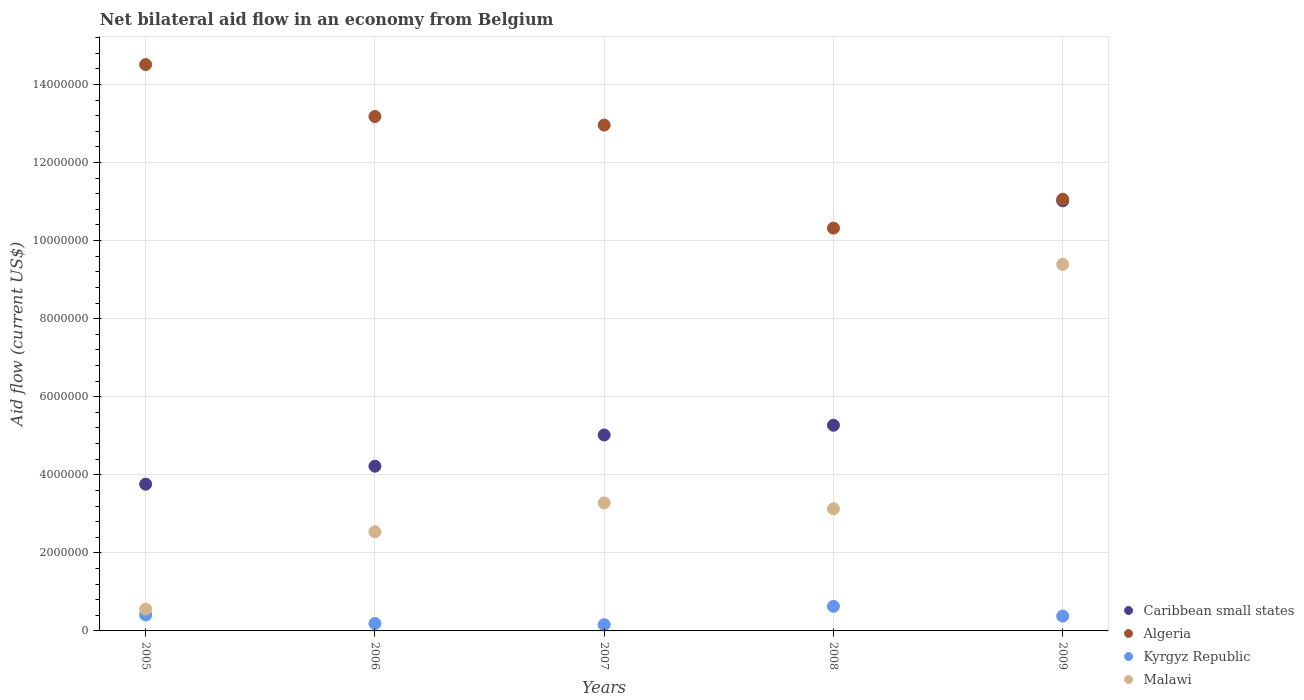How many different coloured dotlines are there?
Offer a terse response. 4. Is the number of dotlines equal to the number of legend labels?
Ensure brevity in your answer.  Yes. What is the net bilateral aid flow in Algeria in 2008?
Make the answer very short. 1.03e+07. Across all years, what is the maximum net bilateral aid flow in Algeria?
Provide a succinct answer. 1.45e+07. Across all years, what is the minimum net bilateral aid flow in Malawi?
Keep it short and to the point. 5.60e+05. What is the total net bilateral aid flow in Kyrgyz Republic in the graph?
Your answer should be very brief. 1.77e+06. What is the difference between the net bilateral aid flow in Malawi in 2005 and the net bilateral aid flow in Caribbean small states in 2008?
Keep it short and to the point. -4.71e+06. What is the average net bilateral aid flow in Algeria per year?
Make the answer very short. 1.24e+07. In the year 2006, what is the difference between the net bilateral aid flow in Kyrgyz Republic and net bilateral aid flow in Algeria?
Ensure brevity in your answer.  -1.30e+07. Is the net bilateral aid flow in Caribbean small states in 2006 less than that in 2008?
Provide a succinct answer. Yes. Is the difference between the net bilateral aid flow in Kyrgyz Republic in 2005 and 2009 greater than the difference between the net bilateral aid flow in Algeria in 2005 and 2009?
Your response must be concise. No. What is the difference between the highest and the second highest net bilateral aid flow in Malawi?
Give a very brief answer. 6.11e+06. What is the difference between the highest and the lowest net bilateral aid flow in Kyrgyz Republic?
Your answer should be very brief. 4.70e+05. In how many years, is the net bilateral aid flow in Caribbean small states greater than the average net bilateral aid flow in Caribbean small states taken over all years?
Provide a succinct answer. 1. Is the net bilateral aid flow in Algeria strictly greater than the net bilateral aid flow in Caribbean small states over the years?
Keep it short and to the point. Yes. Is the net bilateral aid flow in Malawi strictly less than the net bilateral aid flow in Kyrgyz Republic over the years?
Make the answer very short. No. How many dotlines are there?
Provide a succinct answer. 4. How many years are there in the graph?
Ensure brevity in your answer.  5. Are the values on the major ticks of Y-axis written in scientific E-notation?
Make the answer very short. No. What is the title of the graph?
Your answer should be very brief. Net bilateral aid flow in an economy from Belgium. What is the Aid flow (current US$) in Caribbean small states in 2005?
Keep it short and to the point. 3.76e+06. What is the Aid flow (current US$) in Algeria in 2005?
Your answer should be very brief. 1.45e+07. What is the Aid flow (current US$) of Malawi in 2005?
Keep it short and to the point. 5.60e+05. What is the Aid flow (current US$) of Caribbean small states in 2006?
Give a very brief answer. 4.22e+06. What is the Aid flow (current US$) in Algeria in 2006?
Keep it short and to the point. 1.32e+07. What is the Aid flow (current US$) in Kyrgyz Republic in 2006?
Offer a terse response. 1.90e+05. What is the Aid flow (current US$) of Malawi in 2006?
Ensure brevity in your answer.  2.54e+06. What is the Aid flow (current US$) in Caribbean small states in 2007?
Your response must be concise. 5.02e+06. What is the Aid flow (current US$) of Algeria in 2007?
Give a very brief answer. 1.30e+07. What is the Aid flow (current US$) of Kyrgyz Republic in 2007?
Offer a very short reply. 1.60e+05. What is the Aid flow (current US$) of Malawi in 2007?
Keep it short and to the point. 3.28e+06. What is the Aid flow (current US$) in Caribbean small states in 2008?
Offer a very short reply. 5.27e+06. What is the Aid flow (current US$) of Algeria in 2008?
Provide a short and direct response. 1.03e+07. What is the Aid flow (current US$) in Kyrgyz Republic in 2008?
Your answer should be very brief. 6.30e+05. What is the Aid flow (current US$) in Malawi in 2008?
Provide a succinct answer. 3.13e+06. What is the Aid flow (current US$) of Caribbean small states in 2009?
Offer a terse response. 1.10e+07. What is the Aid flow (current US$) of Algeria in 2009?
Provide a succinct answer. 1.11e+07. What is the Aid flow (current US$) of Kyrgyz Republic in 2009?
Your answer should be compact. 3.80e+05. What is the Aid flow (current US$) of Malawi in 2009?
Your response must be concise. 9.39e+06. Across all years, what is the maximum Aid flow (current US$) in Caribbean small states?
Keep it short and to the point. 1.10e+07. Across all years, what is the maximum Aid flow (current US$) in Algeria?
Make the answer very short. 1.45e+07. Across all years, what is the maximum Aid flow (current US$) in Kyrgyz Republic?
Offer a very short reply. 6.30e+05. Across all years, what is the maximum Aid flow (current US$) of Malawi?
Offer a terse response. 9.39e+06. Across all years, what is the minimum Aid flow (current US$) of Caribbean small states?
Ensure brevity in your answer.  3.76e+06. Across all years, what is the minimum Aid flow (current US$) in Algeria?
Provide a succinct answer. 1.03e+07. Across all years, what is the minimum Aid flow (current US$) in Malawi?
Keep it short and to the point. 5.60e+05. What is the total Aid flow (current US$) of Caribbean small states in the graph?
Provide a short and direct response. 2.93e+07. What is the total Aid flow (current US$) in Algeria in the graph?
Provide a short and direct response. 6.20e+07. What is the total Aid flow (current US$) in Kyrgyz Republic in the graph?
Give a very brief answer. 1.77e+06. What is the total Aid flow (current US$) of Malawi in the graph?
Make the answer very short. 1.89e+07. What is the difference between the Aid flow (current US$) in Caribbean small states in 2005 and that in 2006?
Provide a succinct answer. -4.60e+05. What is the difference between the Aid flow (current US$) of Algeria in 2005 and that in 2006?
Make the answer very short. 1.33e+06. What is the difference between the Aid flow (current US$) of Kyrgyz Republic in 2005 and that in 2006?
Your answer should be very brief. 2.20e+05. What is the difference between the Aid flow (current US$) of Malawi in 2005 and that in 2006?
Your answer should be compact. -1.98e+06. What is the difference between the Aid flow (current US$) in Caribbean small states in 2005 and that in 2007?
Your answer should be very brief. -1.26e+06. What is the difference between the Aid flow (current US$) of Algeria in 2005 and that in 2007?
Offer a very short reply. 1.55e+06. What is the difference between the Aid flow (current US$) of Malawi in 2005 and that in 2007?
Ensure brevity in your answer.  -2.72e+06. What is the difference between the Aid flow (current US$) of Caribbean small states in 2005 and that in 2008?
Offer a very short reply. -1.51e+06. What is the difference between the Aid flow (current US$) in Algeria in 2005 and that in 2008?
Your answer should be compact. 4.19e+06. What is the difference between the Aid flow (current US$) of Kyrgyz Republic in 2005 and that in 2008?
Keep it short and to the point. -2.20e+05. What is the difference between the Aid flow (current US$) in Malawi in 2005 and that in 2008?
Your answer should be very brief. -2.57e+06. What is the difference between the Aid flow (current US$) of Caribbean small states in 2005 and that in 2009?
Your answer should be compact. -7.26e+06. What is the difference between the Aid flow (current US$) of Algeria in 2005 and that in 2009?
Offer a very short reply. 3.45e+06. What is the difference between the Aid flow (current US$) in Kyrgyz Republic in 2005 and that in 2009?
Your answer should be very brief. 3.00e+04. What is the difference between the Aid flow (current US$) in Malawi in 2005 and that in 2009?
Provide a short and direct response. -8.83e+06. What is the difference between the Aid flow (current US$) of Caribbean small states in 2006 and that in 2007?
Keep it short and to the point. -8.00e+05. What is the difference between the Aid flow (current US$) in Algeria in 2006 and that in 2007?
Make the answer very short. 2.20e+05. What is the difference between the Aid flow (current US$) of Malawi in 2006 and that in 2007?
Provide a succinct answer. -7.40e+05. What is the difference between the Aid flow (current US$) of Caribbean small states in 2006 and that in 2008?
Provide a short and direct response. -1.05e+06. What is the difference between the Aid flow (current US$) in Algeria in 2006 and that in 2008?
Make the answer very short. 2.86e+06. What is the difference between the Aid flow (current US$) in Kyrgyz Republic in 2006 and that in 2008?
Make the answer very short. -4.40e+05. What is the difference between the Aid flow (current US$) in Malawi in 2006 and that in 2008?
Make the answer very short. -5.90e+05. What is the difference between the Aid flow (current US$) of Caribbean small states in 2006 and that in 2009?
Provide a succinct answer. -6.80e+06. What is the difference between the Aid flow (current US$) of Algeria in 2006 and that in 2009?
Ensure brevity in your answer.  2.12e+06. What is the difference between the Aid flow (current US$) of Kyrgyz Republic in 2006 and that in 2009?
Give a very brief answer. -1.90e+05. What is the difference between the Aid flow (current US$) in Malawi in 2006 and that in 2009?
Your response must be concise. -6.85e+06. What is the difference between the Aid flow (current US$) of Algeria in 2007 and that in 2008?
Offer a terse response. 2.64e+06. What is the difference between the Aid flow (current US$) of Kyrgyz Republic in 2007 and that in 2008?
Provide a succinct answer. -4.70e+05. What is the difference between the Aid flow (current US$) in Malawi in 2007 and that in 2008?
Give a very brief answer. 1.50e+05. What is the difference between the Aid flow (current US$) of Caribbean small states in 2007 and that in 2009?
Provide a succinct answer. -6.00e+06. What is the difference between the Aid flow (current US$) in Algeria in 2007 and that in 2009?
Keep it short and to the point. 1.90e+06. What is the difference between the Aid flow (current US$) of Kyrgyz Republic in 2007 and that in 2009?
Give a very brief answer. -2.20e+05. What is the difference between the Aid flow (current US$) of Malawi in 2007 and that in 2009?
Your response must be concise. -6.11e+06. What is the difference between the Aid flow (current US$) of Caribbean small states in 2008 and that in 2009?
Make the answer very short. -5.75e+06. What is the difference between the Aid flow (current US$) in Algeria in 2008 and that in 2009?
Provide a succinct answer. -7.40e+05. What is the difference between the Aid flow (current US$) of Malawi in 2008 and that in 2009?
Offer a terse response. -6.26e+06. What is the difference between the Aid flow (current US$) of Caribbean small states in 2005 and the Aid flow (current US$) of Algeria in 2006?
Keep it short and to the point. -9.42e+06. What is the difference between the Aid flow (current US$) of Caribbean small states in 2005 and the Aid flow (current US$) of Kyrgyz Republic in 2006?
Give a very brief answer. 3.57e+06. What is the difference between the Aid flow (current US$) in Caribbean small states in 2005 and the Aid flow (current US$) in Malawi in 2006?
Offer a very short reply. 1.22e+06. What is the difference between the Aid flow (current US$) of Algeria in 2005 and the Aid flow (current US$) of Kyrgyz Republic in 2006?
Your answer should be compact. 1.43e+07. What is the difference between the Aid flow (current US$) of Algeria in 2005 and the Aid flow (current US$) of Malawi in 2006?
Make the answer very short. 1.20e+07. What is the difference between the Aid flow (current US$) in Kyrgyz Republic in 2005 and the Aid flow (current US$) in Malawi in 2006?
Keep it short and to the point. -2.13e+06. What is the difference between the Aid flow (current US$) in Caribbean small states in 2005 and the Aid flow (current US$) in Algeria in 2007?
Your response must be concise. -9.20e+06. What is the difference between the Aid flow (current US$) in Caribbean small states in 2005 and the Aid flow (current US$) in Kyrgyz Republic in 2007?
Provide a succinct answer. 3.60e+06. What is the difference between the Aid flow (current US$) in Algeria in 2005 and the Aid flow (current US$) in Kyrgyz Republic in 2007?
Your response must be concise. 1.44e+07. What is the difference between the Aid flow (current US$) in Algeria in 2005 and the Aid flow (current US$) in Malawi in 2007?
Give a very brief answer. 1.12e+07. What is the difference between the Aid flow (current US$) of Kyrgyz Republic in 2005 and the Aid flow (current US$) of Malawi in 2007?
Provide a succinct answer. -2.87e+06. What is the difference between the Aid flow (current US$) of Caribbean small states in 2005 and the Aid flow (current US$) of Algeria in 2008?
Your response must be concise. -6.56e+06. What is the difference between the Aid flow (current US$) in Caribbean small states in 2005 and the Aid flow (current US$) in Kyrgyz Republic in 2008?
Keep it short and to the point. 3.13e+06. What is the difference between the Aid flow (current US$) in Caribbean small states in 2005 and the Aid flow (current US$) in Malawi in 2008?
Offer a terse response. 6.30e+05. What is the difference between the Aid flow (current US$) of Algeria in 2005 and the Aid flow (current US$) of Kyrgyz Republic in 2008?
Make the answer very short. 1.39e+07. What is the difference between the Aid flow (current US$) in Algeria in 2005 and the Aid flow (current US$) in Malawi in 2008?
Give a very brief answer. 1.14e+07. What is the difference between the Aid flow (current US$) of Kyrgyz Republic in 2005 and the Aid flow (current US$) of Malawi in 2008?
Offer a terse response. -2.72e+06. What is the difference between the Aid flow (current US$) of Caribbean small states in 2005 and the Aid flow (current US$) of Algeria in 2009?
Offer a terse response. -7.30e+06. What is the difference between the Aid flow (current US$) of Caribbean small states in 2005 and the Aid flow (current US$) of Kyrgyz Republic in 2009?
Keep it short and to the point. 3.38e+06. What is the difference between the Aid flow (current US$) in Caribbean small states in 2005 and the Aid flow (current US$) in Malawi in 2009?
Provide a succinct answer. -5.63e+06. What is the difference between the Aid flow (current US$) in Algeria in 2005 and the Aid flow (current US$) in Kyrgyz Republic in 2009?
Your answer should be compact. 1.41e+07. What is the difference between the Aid flow (current US$) of Algeria in 2005 and the Aid flow (current US$) of Malawi in 2009?
Offer a very short reply. 5.12e+06. What is the difference between the Aid flow (current US$) of Kyrgyz Republic in 2005 and the Aid flow (current US$) of Malawi in 2009?
Your response must be concise. -8.98e+06. What is the difference between the Aid flow (current US$) of Caribbean small states in 2006 and the Aid flow (current US$) of Algeria in 2007?
Give a very brief answer. -8.74e+06. What is the difference between the Aid flow (current US$) in Caribbean small states in 2006 and the Aid flow (current US$) in Kyrgyz Republic in 2007?
Provide a succinct answer. 4.06e+06. What is the difference between the Aid flow (current US$) in Caribbean small states in 2006 and the Aid flow (current US$) in Malawi in 2007?
Ensure brevity in your answer.  9.40e+05. What is the difference between the Aid flow (current US$) of Algeria in 2006 and the Aid flow (current US$) of Kyrgyz Republic in 2007?
Keep it short and to the point. 1.30e+07. What is the difference between the Aid flow (current US$) of Algeria in 2006 and the Aid flow (current US$) of Malawi in 2007?
Offer a terse response. 9.90e+06. What is the difference between the Aid flow (current US$) of Kyrgyz Republic in 2006 and the Aid flow (current US$) of Malawi in 2007?
Keep it short and to the point. -3.09e+06. What is the difference between the Aid flow (current US$) of Caribbean small states in 2006 and the Aid flow (current US$) of Algeria in 2008?
Offer a terse response. -6.10e+06. What is the difference between the Aid flow (current US$) of Caribbean small states in 2006 and the Aid flow (current US$) of Kyrgyz Republic in 2008?
Your response must be concise. 3.59e+06. What is the difference between the Aid flow (current US$) in Caribbean small states in 2006 and the Aid flow (current US$) in Malawi in 2008?
Offer a very short reply. 1.09e+06. What is the difference between the Aid flow (current US$) in Algeria in 2006 and the Aid flow (current US$) in Kyrgyz Republic in 2008?
Your answer should be very brief. 1.26e+07. What is the difference between the Aid flow (current US$) in Algeria in 2006 and the Aid flow (current US$) in Malawi in 2008?
Provide a succinct answer. 1.00e+07. What is the difference between the Aid flow (current US$) of Kyrgyz Republic in 2006 and the Aid flow (current US$) of Malawi in 2008?
Your answer should be compact. -2.94e+06. What is the difference between the Aid flow (current US$) of Caribbean small states in 2006 and the Aid flow (current US$) of Algeria in 2009?
Your response must be concise. -6.84e+06. What is the difference between the Aid flow (current US$) in Caribbean small states in 2006 and the Aid flow (current US$) in Kyrgyz Republic in 2009?
Ensure brevity in your answer.  3.84e+06. What is the difference between the Aid flow (current US$) of Caribbean small states in 2006 and the Aid flow (current US$) of Malawi in 2009?
Ensure brevity in your answer.  -5.17e+06. What is the difference between the Aid flow (current US$) of Algeria in 2006 and the Aid flow (current US$) of Kyrgyz Republic in 2009?
Provide a short and direct response. 1.28e+07. What is the difference between the Aid flow (current US$) of Algeria in 2006 and the Aid flow (current US$) of Malawi in 2009?
Ensure brevity in your answer.  3.79e+06. What is the difference between the Aid flow (current US$) in Kyrgyz Republic in 2006 and the Aid flow (current US$) in Malawi in 2009?
Your answer should be very brief. -9.20e+06. What is the difference between the Aid flow (current US$) in Caribbean small states in 2007 and the Aid flow (current US$) in Algeria in 2008?
Provide a succinct answer. -5.30e+06. What is the difference between the Aid flow (current US$) of Caribbean small states in 2007 and the Aid flow (current US$) of Kyrgyz Republic in 2008?
Make the answer very short. 4.39e+06. What is the difference between the Aid flow (current US$) in Caribbean small states in 2007 and the Aid flow (current US$) in Malawi in 2008?
Ensure brevity in your answer.  1.89e+06. What is the difference between the Aid flow (current US$) in Algeria in 2007 and the Aid flow (current US$) in Kyrgyz Republic in 2008?
Provide a succinct answer. 1.23e+07. What is the difference between the Aid flow (current US$) of Algeria in 2007 and the Aid flow (current US$) of Malawi in 2008?
Your answer should be very brief. 9.83e+06. What is the difference between the Aid flow (current US$) in Kyrgyz Republic in 2007 and the Aid flow (current US$) in Malawi in 2008?
Offer a very short reply. -2.97e+06. What is the difference between the Aid flow (current US$) in Caribbean small states in 2007 and the Aid flow (current US$) in Algeria in 2009?
Your answer should be very brief. -6.04e+06. What is the difference between the Aid flow (current US$) in Caribbean small states in 2007 and the Aid flow (current US$) in Kyrgyz Republic in 2009?
Ensure brevity in your answer.  4.64e+06. What is the difference between the Aid flow (current US$) of Caribbean small states in 2007 and the Aid flow (current US$) of Malawi in 2009?
Your answer should be very brief. -4.37e+06. What is the difference between the Aid flow (current US$) in Algeria in 2007 and the Aid flow (current US$) in Kyrgyz Republic in 2009?
Make the answer very short. 1.26e+07. What is the difference between the Aid flow (current US$) of Algeria in 2007 and the Aid flow (current US$) of Malawi in 2009?
Your response must be concise. 3.57e+06. What is the difference between the Aid flow (current US$) in Kyrgyz Republic in 2007 and the Aid flow (current US$) in Malawi in 2009?
Provide a short and direct response. -9.23e+06. What is the difference between the Aid flow (current US$) of Caribbean small states in 2008 and the Aid flow (current US$) of Algeria in 2009?
Your response must be concise. -5.79e+06. What is the difference between the Aid flow (current US$) in Caribbean small states in 2008 and the Aid flow (current US$) in Kyrgyz Republic in 2009?
Keep it short and to the point. 4.89e+06. What is the difference between the Aid flow (current US$) of Caribbean small states in 2008 and the Aid flow (current US$) of Malawi in 2009?
Give a very brief answer. -4.12e+06. What is the difference between the Aid flow (current US$) in Algeria in 2008 and the Aid flow (current US$) in Kyrgyz Republic in 2009?
Your answer should be very brief. 9.94e+06. What is the difference between the Aid flow (current US$) in Algeria in 2008 and the Aid flow (current US$) in Malawi in 2009?
Provide a succinct answer. 9.30e+05. What is the difference between the Aid flow (current US$) in Kyrgyz Republic in 2008 and the Aid flow (current US$) in Malawi in 2009?
Your answer should be very brief. -8.76e+06. What is the average Aid flow (current US$) of Caribbean small states per year?
Make the answer very short. 5.86e+06. What is the average Aid flow (current US$) of Algeria per year?
Provide a short and direct response. 1.24e+07. What is the average Aid flow (current US$) in Kyrgyz Republic per year?
Make the answer very short. 3.54e+05. What is the average Aid flow (current US$) of Malawi per year?
Ensure brevity in your answer.  3.78e+06. In the year 2005, what is the difference between the Aid flow (current US$) in Caribbean small states and Aid flow (current US$) in Algeria?
Provide a succinct answer. -1.08e+07. In the year 2005, what is the difference between the Aid flow (current US$) in Caribbean small states and Aid flow (current US$) in Kyrgyz Republic?
Ensure brevity in your answer.  3.35e+06. In the year 2005, what is the difference between the Aid flow (current US$) of Caribbean small states and Aid flow (current US$) of Malawi?
Your response must be concise. 3.20e+06. In the year 2005, what is the difference between the Aid flow (current US$) in Algeria and Aid flow (current US$) in Kyrgyz Republic?
Your response must be concise. 1.41e+07. In the year 2005, what is the difference between the Aid flow (current US$) in Algeria and Aid flow (current US$) in Malawi?
Ensure brevity in your answer.  1.40e+07. In the year 2006, what is the difference between the Aid flow (current US$) in Caribbean small states and Aid flow (current US$) in Algeria?
Make the answer very short. -8.96e+06. In the year 2006, what is the difference between the Aid flow (current US$) in Caribbean small states and Aid flow (current US$) in Kyrgyz Republic?
Provide a succinct answer. 4.03e+06. In the year 2006, what is the difference between the Aid flow (current US$) of Caribbean small states and Aid flow (current US$) of Malawi?
Your response must be concise. 1.68e+06. In the year 2006, what is the difference between the Aid flow (current US$) in Algeria and Aid flow (current US$) in Kyrgyz Republic?
Give a very brief answer. 1.30e+07. In the year 2006, what is the difference between the Aid flow (current US$) of Algeria and Aid flow (current US$) of Malawi?
Offer a very short reply. 1.06e+07. In the year 2006, what is the difference between the Aid flow (current US$) in Kyrgyz Republic and Aid flow (current US$) in Malawi?
Your answer should be compact. -2.35e+06. In the year 2007, what is the difference between the Aid flow (current US$) in Caribbean small states and Aid flow (current US$) in Algeria?
Make the answer very short. -7.94e+06. In the year 2007, what is the difference between the Aid flow (current US$) of Caribbean small states and Aid flow (current US$) of Kyrgyz Republic?
Give a very brief answer. 4.86e+06. In the year 2007, what is the difference between the Aid flow (current US$) in Caribbean small states and Aid flow (current US$) in Malawi?
Your response must be concise. 1.74e+06. In the year 2007, what is the difference between the Aid flow (current US$) of Algeria and Aid flow (current US$) of Kyrgyz Republic?
Your answer should be very brief. 1.28e+07. In the year 2007, what is the difference between the Aid flow (current US$) in Algeria and Aid flow (current US$) in Malawi?
Offer a terse response. 9.68e+06. In the year 2007, what is the difference between the Aid flow (current US$) in Kyrgyz Republic and Aid flow (current US$) in Malawi?
Give a very brief answer. -3.12e+06. In the year 2008, what is the difference between the Aid flow (current US$) in Caribbean small states and Aid flow (current US$) in Algeria?
Ensure brevity in your answer.  -5.05e+06. In the year 2008, what is the difference between the Aid flow (current US$) in Caribbean small states and Aid flow (current US$) in Kyrgyz Republic?
Your response must be concise. 4.64e+06. In the year 2008, what is the difference between the Aid flow (current US$) in Caribbean small states and Aid flow (current US$) in Malawi?
Give a very brief answer. 2.14e+06. In the year 2008, what is the difference between the Aid flow (current US$) of Algeria and Aid flow (current US$) of Kyrgyz Republic?
Give a very brief answer. 9.69e+06. In the year 2008, what is the difference between the Aid flow (current US$) in Algeria and Aid flow (current US$) in Malawi?
Give a very brief answer. 7.19e+06. In the year 2008, what is the difference between the Aid flow (current US$) of Kyrgyz Republic and Aid flow (current US$) of Malawi?
Your answer should be compact. -2.50e+06. In the year 2009, what is the difference between the Aid flow (current US$) in Caribbean small states and Aid flow (current US$) in Algeria?
Your answer should be very brief. -4.00e+04. In the year 2009, what is the difference between the Aid flow (current US$) in Caribbean small states and Aid flow (current US$) in Kyrgyz Republic?
Ensure brevity in your answer.  1.06e+07. In the year 2009, what is the difference between the Aid flow (current US$) in Caribbean small states and Aid flow (current US$) in Malawi?
Make the answer very short. 1.63e+06. In the year 2009, what is the difference between the Aid flow (current US$) of Algeria and Aid flow (current US$) of Kyrgyz Republic?
Offer a very short reply. 1.07e+07. In the year 2009, what is the difference between the Aid flow (current US$) of Algeria and Aid flow (current US$) of Malawi?
Offer a very short reply. 1.67e+06. In the year 2009, what is the difference between the Aid flow (current US$) of Kyrgyz Republic and Aid flow (current US$) of Malawi?
Give a very brief answer. -9.01e+06. What is the ratio of the Aid flow (current US$) of Caribbean small states in 2005 to that in 2006?
Provide a short and direct response. 0.89. What is the ratio of the Aid flow (current US$) in Algeria in 2005 to that in 2006?
Keep it short and to the point. 1.1. What is the ratio of the Aid flow (current US$) of Kyrgyz Republic in 2005 to that in 2006?
Ensure brevity in your answer.  2.16. What is the ratio of the Aid flow (current US$) of Malawi in 2005 to that in 2006?
Your answer should be very brief. 0.22. What is the ratio of the Aid flow (current US$) in Caribbean small states in 2005 to that in 2007?
Make the answer very short. 0.75. What is the ratio of the Aid flow (current US$) of Algeria in 2005 to that in 2007?
Offer a very short reply. 1.12. What is the ratio of the Aid flow (current US$) of Kyrgyz Republic in 2005 to that in 2007?
Make the answer very short. 2.56. What is the ratio of the Aid flow (current US$) of Malawi in 2005 to that in 2007?
Offer a very short reply. 0.17. What is the ratio of the Aid flow (current US$) of Caribbean small states in 2005 to that in 2008?
Ensure brevity in your answer.  0.71. What is the ratio of the Aid flow (current US$) of Algeria in 2005 to that in 2008?
Your answer should be very brief. 1.41. What is the ratio of the Aid flow (current US$) of Kyrgyz Republic in 2005 to that in 2008?
Give a very brief answer. 0.65. What is the ratio of the Aid flow (current US$) in Malawi in 2005 to that in 2008?
Provide a short and direct response. 0.18. What is the ratio of the Aid flow (current US$) in Caribbean small states in 2005 to that in 2009?
Provide a short and direct response. 0.34. What is the ratio of the Aid flow (current US$) of Algeria in 2005 to that in 2009?
Offer a very short reply. 1.31. What is the ratio of the Aid flow (current US$) in Kyrgyz Republic in 2005 to that in 2009?
Give a very brief answer. 1.08. What is the ratio of the Aid flow (current US$) of Malawi in 2005 to that in 2009?
Give a very brief answer. 0.06. What is the ratio of the Aid flow (current US$) of Caribbean small states in 2006 to that in 2007?
Offer a very short reply. 0.84. What is the ratio of the Aid flow (current US$) of Kyrgyz Republic in 2006 to that in 2007?
Make the answer very short. 1.19. What is the ratio of the Aid flow (current US$) of Malawi in 2006 to that in 2007?
Provide a succinct answer. 0.77. What is the ratio of the Aid flow (current US$) of Caribbean small states in 2006 to that in 2008?
Ensure brevity in your answer.  0.8. What is the ratio of the Aid flow (current US$) of Algeria in 2006 to that in 2008?
Offer a terse response. 1.28. What is the ratio of the Aid flow (current US$) of Kyrgyz Republic in 2006 to that in 2008?
Offer a very short reply. 0.3. What is the ratio of the Aid flow (current US$) of Malawi in 2006 to that in 2008?
Your answer should be very brief. 0.81. What is the ratio of the Aid flow (current US$) of Caribbean small states in 2006 to that in 2009?
Your response must be concise. 0.38. What is the ratio of the Aid flow (current US$) of Algeria in 2006 to that in 2009?
Give a very brief answer. 1.19. What is the ratio of the Aid flow (current US$) of Malawi in 2006 to that in 2009?
Make the answer very short. 0.27. What is the ratio of the Aid flow (current US$) of Caribbean small states in 2007 to that in 2008?
Your response must be concise. 0.95. What is the ratio of the Aid flow (current US$) in Algeria in 2007 to that in 2008?
Offer a very short reply. 1.26. What is the ratio of the Aid flow (current US$) of Kyrgyz Republic in 2007 to that in 2008?
Ensure brevity in your answer.  0.25. What is the ratio of the Aid flow (current US$) in Malawi in 2007 to that in 2008?
Give a very brief answer. 1.05. What is the ratio of the Aid flow (current US$) of Caribbean small states in 2007 to that in 2009?
Offer a very short reply. 0.46. What is the ratio of the Aid flow (current US$) of Algeria in 2007 to that in 2009?
Your response must be concise. 1.17. What is the ratio of the Aid flow (current US$) in Kyrgyz Republic in 2007 to that in 2009?
Keep it short and to the point. 0.42. What is the ratio of the Aid flow (current US$) of Malawi in 2007 to that in 2009?
Offer a very short reply. 0.35. What is the ratio of the Aid flow (current US$) in Caribbean small states in 2008 to that in 2009?
Provide a short and direct response. 0.48. What is the ratio of the Aid flow (current US$) of Algeria in 2008 to that in 2009?
Your answer should be compact. 0.93. What is the ratio of the Aid flow (current US$) in Kyrgyz Republic in 2008 to that in 2009?
Provide a succinct answer. 1.66. What is the difference between the highest and the second highest Aid flow (current US$) of Caribbean small states?
Provide a succinct answer. 5.75e+06. What is the difference between the highest and the second highest Aid flow (current US$) of Algeria?
Provide a succinct answer. 1.33e+06. What is the difference between the highest and the second highest Aid flow (current US$) of Kyrgyz Republic?
Provide a short and direct response. 2.20e+05. What is the difference between the highest and the second highest Aid flow (current US$) of Malawi?
Your answer should be compact. 6.11e+06. What is the difference between the highest and the lowest Aid flow (current US$) in Caribbean small states?
Offer a terse response. 7.26e+06. What is the difference between the highest and the lowest Aid flow (current US$) of Algeria?
Ensure brevity in your answer.  4.19e+06. What is the difference between the highest and the lowest Aid flow (current US$) in Malawi?
Offer a terse response. 8.83e+06. 